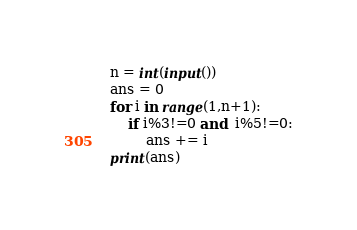<code> <loc_0><loc_0><loc_500><loc_500><_Python_>n = int(input())
ans = 0
for i in range(1,n+1):
    if i%3!=0 and  i%5!=0:
        ans += i
print(ans)
</code> 